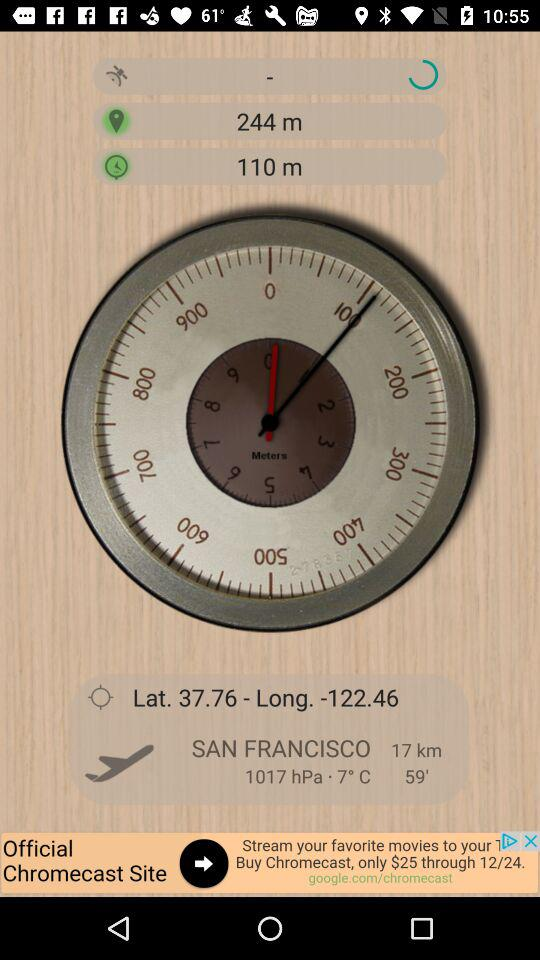What is the longitude value? The longitude value is -122.46. 